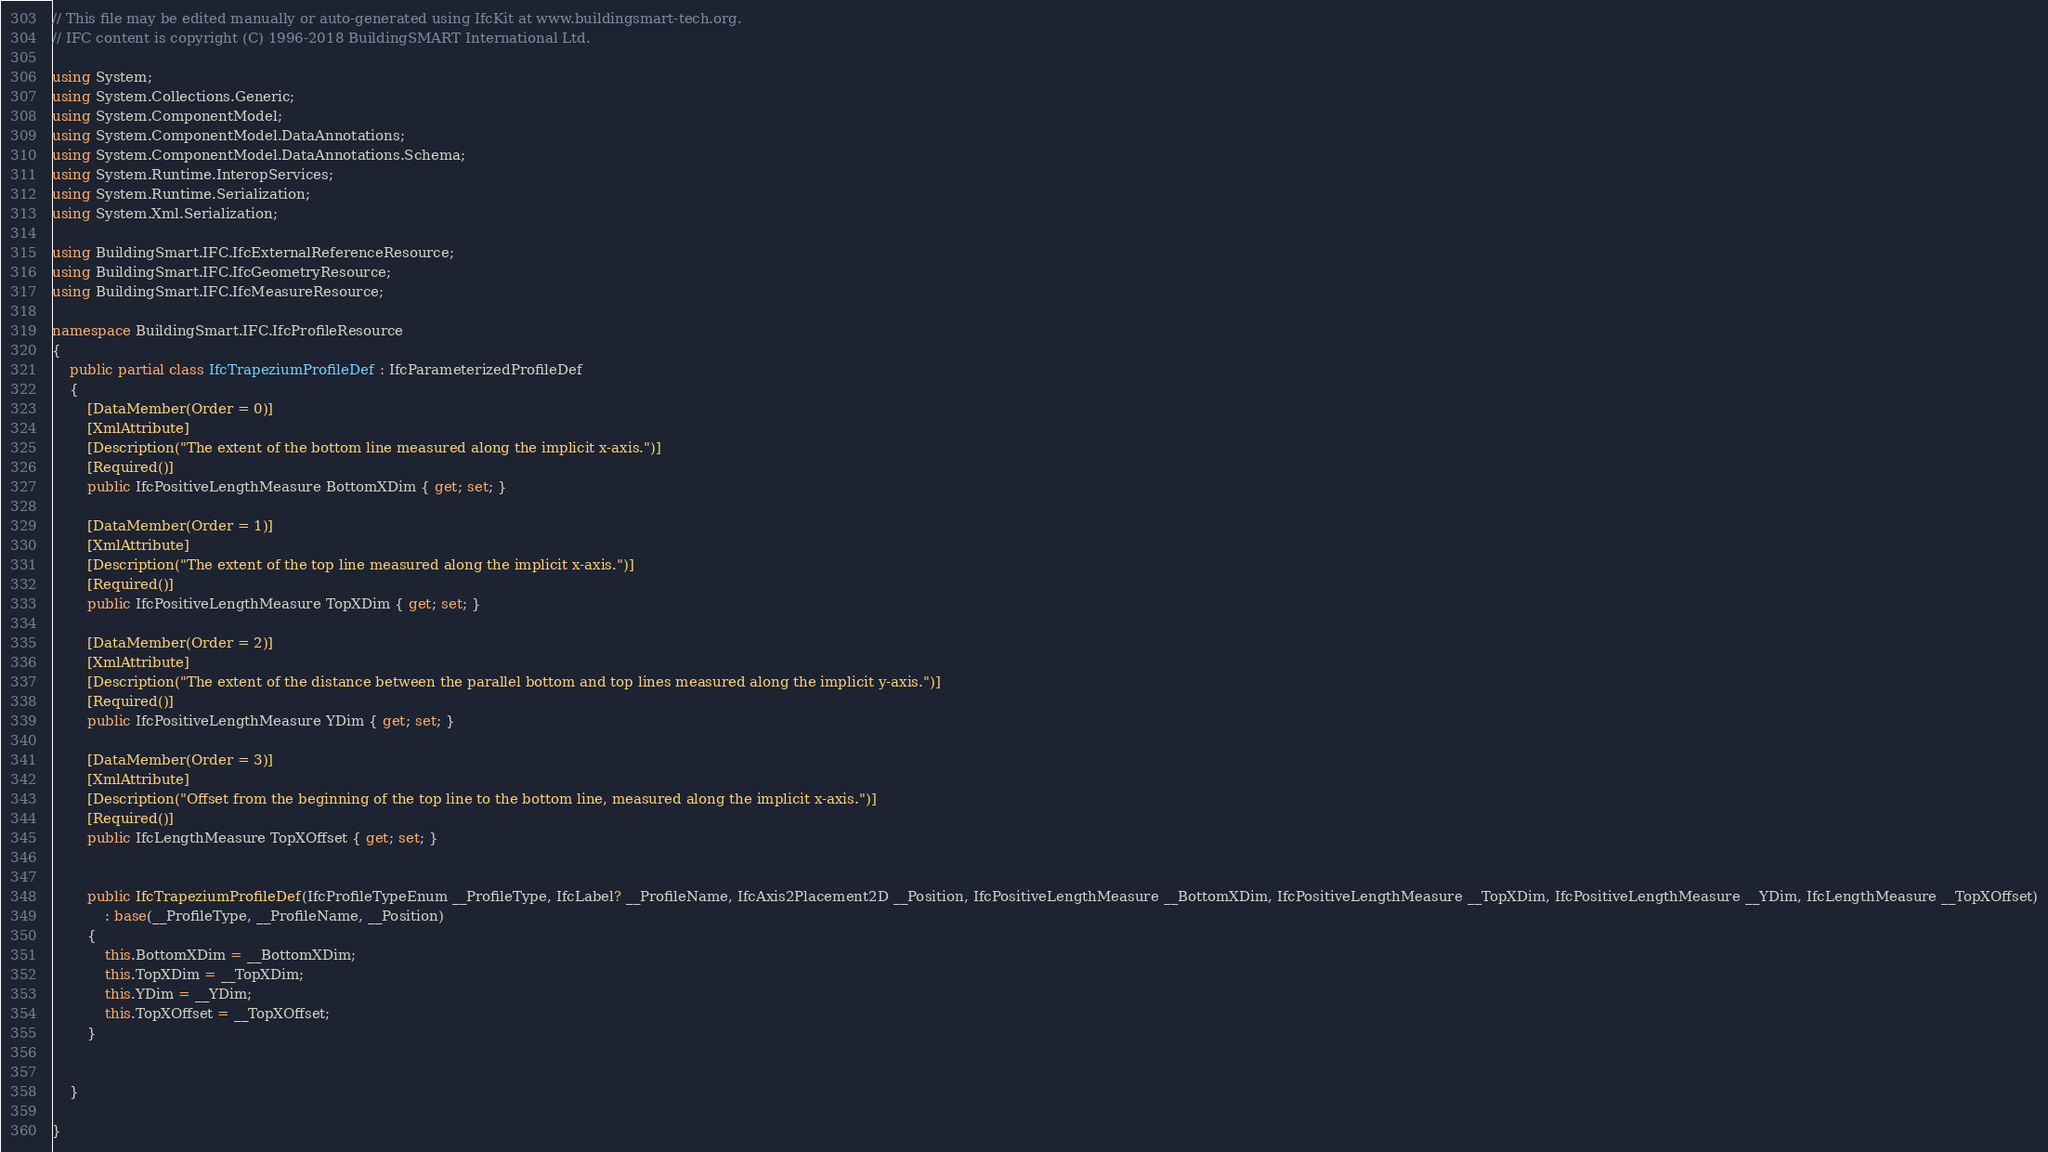Convert code to text. <code><loc_0><loc_0><loc_500><loc_500><_C#_>// This file may be edited manually or auto-generated using IfcKit at www.buildingsmart-tech.org.
// IFC content is copyright (C) 1996-2018 BuildingSMART International Ltd.

using System;
using System.Collections.Generic;
using System.ComponentModel;
using System.ComponentModel.DataAnnotations;
using System.ComponentModel.DataAnnotations.Schema;
using System.Runtime.InteropServices;
using System.Runtime.Serialization;
using System.Xml.Serialization;

using BuildingSmart.IFC.IfcExternalReferenceResource;
using BuildingSmart.IFC.IfcGeometryResource;
using BuildingSmart.IFC.IfcMeasureResource;

namespace BuildingSmart.IFC.IfcProfileResource
{
	public partial class IfcTrapeziumProfileDef : IfcParameterizedProfileDef
	{
		[DataMember(Order = 0)] 
		[XmlAttribute]
		[Description("The extent of the bottom line measured along the implicit x-axis.")]
		[Required()]
		public IfcPositiveLengthMeasure BottomXDim { get; set; }
	
		[DataMember(Order = 1)] 
		[XmlAttribute]
		[Description("The extent of the top line measured along the implicit x-axis.")]
		[Required()]
		public IfcPositiveLengthMeasure TopXDim { get; set; }
	
		[DataMember(Order = 2)] 
		[XmlAttribute]
		[Description("The extent of the distance between the parallel bottom and top lines measured along the implicit y-axis.")]
		[Required()]
		public IfcPositiveLengthMeasure YDim { get; set; }
	
		[DataMember(Order = 3)] 
		[XmlAttribute]
		[Description("Offset from the beginning of the top line to the bottom line, measured along the implicit x-axis.")]
		[Required()]
		public IfcLengthMeasure TopXOffset { get; set; }
	
	
		public IfcTrapeziumProfileDef(IfcProfileTypeEnum __ProfileType, IfcLabel? __ProfileName, IfcAxis2Placement2D __Position, IfcPositiveLengthMeasure __BottomXDim, IfcPositiveLengthMeasure __TopXDim, IfcPositiveLengthMeasure __YDim, IfcLengthMeasure __TopXOffset)
			: base(__ProfileType, __ProfileName, __Position)
		{
			this.BottomXDim = __BottomXDim;
			this.TopXDim = __TopXDim;
			this.YDim = __YDim;
			this.TopXOffset = __TopXOffset;
		}
	
	
	}
	
}
</code> 